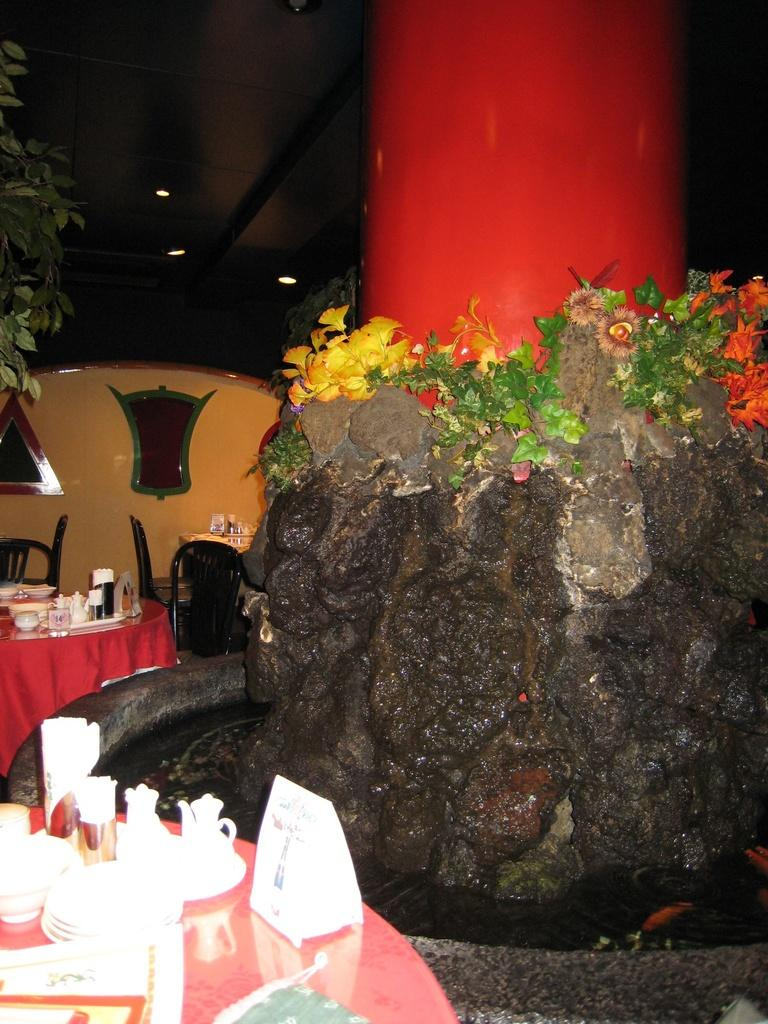What type of furniture is present in the image? There are tables and chairs in the image. What can be seen hanging from the ceiling in the image? There are lights in the image. What type of vegetation is present in the image? There are plants and flowers in the image. What is the liquid element visible in the image? There is water visible in the image. What color is the powder on the table in the image? There is no powder present on the table in the image. Can you describe the veins in the flowers in the image? There are no veins visible in the flowers in the image, as flowers do not have veins like animals or humans. 